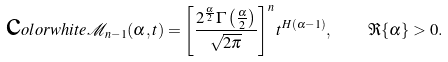<formula> <loc_0><loc_0><loc_500><loc_500>\text  color{white} { \mathcal { M } _ { n - 1 } ( \alpha , t ) } = \left [ \frac { 2 ^ { \frac { \alpha } { 2 } } \Gamma \left ( \frac { \alpha } { 2 } \right ) } { \sqrt { 2 \pi } } \right ] ^ { n } t ^ { H ( \alpha - 1 ) } , \quad \Re \{ \alpha \} > 0 .</formula> 